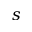Convert formula to latex. <formula><loc_0><loc_0><loc_500><loc_500>s</formula> 